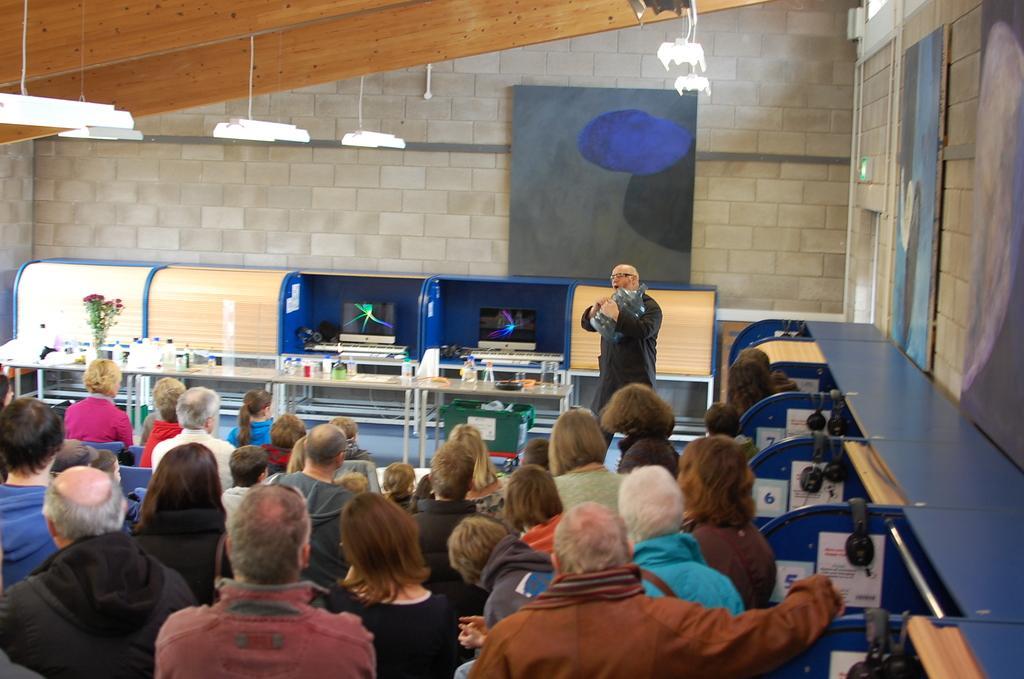Please provide a concise description of this image. On this table there are bottles, flowers and objects. This man is holding a water can. In-front of this man there are people. Here we can see headsets, monitors and posters. Pictures are on the wall. Lights are attached to the rooftop. 